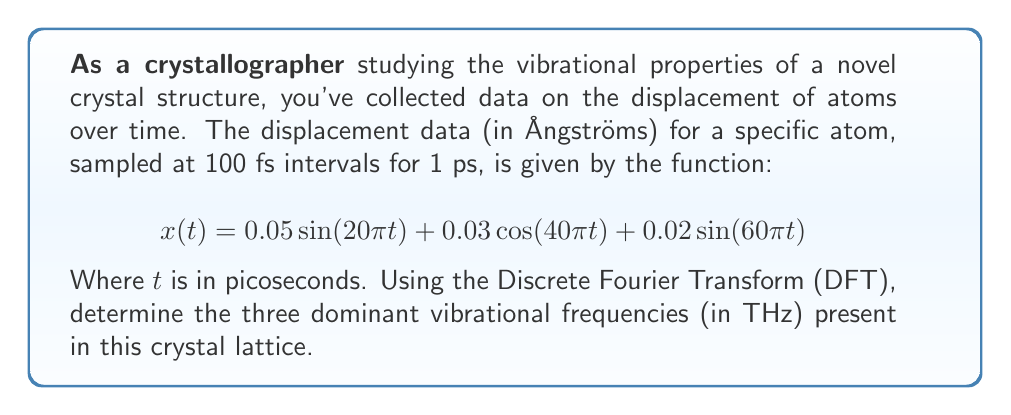Can you answer this question? To solve this problem, we'll follow these steps:

1) First, we need to understand that the Discrete Fourier Transform will help us identify the frequency components in our signal.

2) The given function is a continuous-time signal, but we're told it's sampled at 100 fs intervals for 1 ps. This means we have 10 samples (1 ps / 100 fs = 10).

3) In the given equation, we can identify three frequency components:
   - $20\pi$ rad/ps
   - $40\pi$ rad/ps
   - $60\pi$ rad/ps

4) To convert from angular frequency (rad/ps) to frequency (THz), we use the formula:
   $$f = \frac{\omega}{2\pi}$$
   Where $f$ is frequency in THz and $\omega$ is angular frequency in rad/ps.

5) Converting each angular frequency:
   - For $20\pi$ rad/ps: $f_1 = \frac{20\pi}{2\pi} = 10$ THz
   - For $40\pi$ rad/ps: $f_2 = \frac{40\pi}{2\pi} = 20$ THz
   - For $60\pi$ rad/ps: $f_3 = \frac{60\pi}{2\pi} = 30$ THz

6) These frequencies correspond to the peaks we would see in the magnitude spectrum of the DFT.

7) The amplitudes of these components (0.05, 0.03, and 0.02) would determine the relative heights of these peaks in the DFT magnitude spectrum.

Therefore, the DFT would reveal three dominant peaks at 10 THz, 20 THz, and 30 THz, corresponding to the three sinusoidal components in the original function.
Answer: The three dominant vibrational frequencies present in the crystal lattice are 10 THz, 20 THz, and 30 THz. 